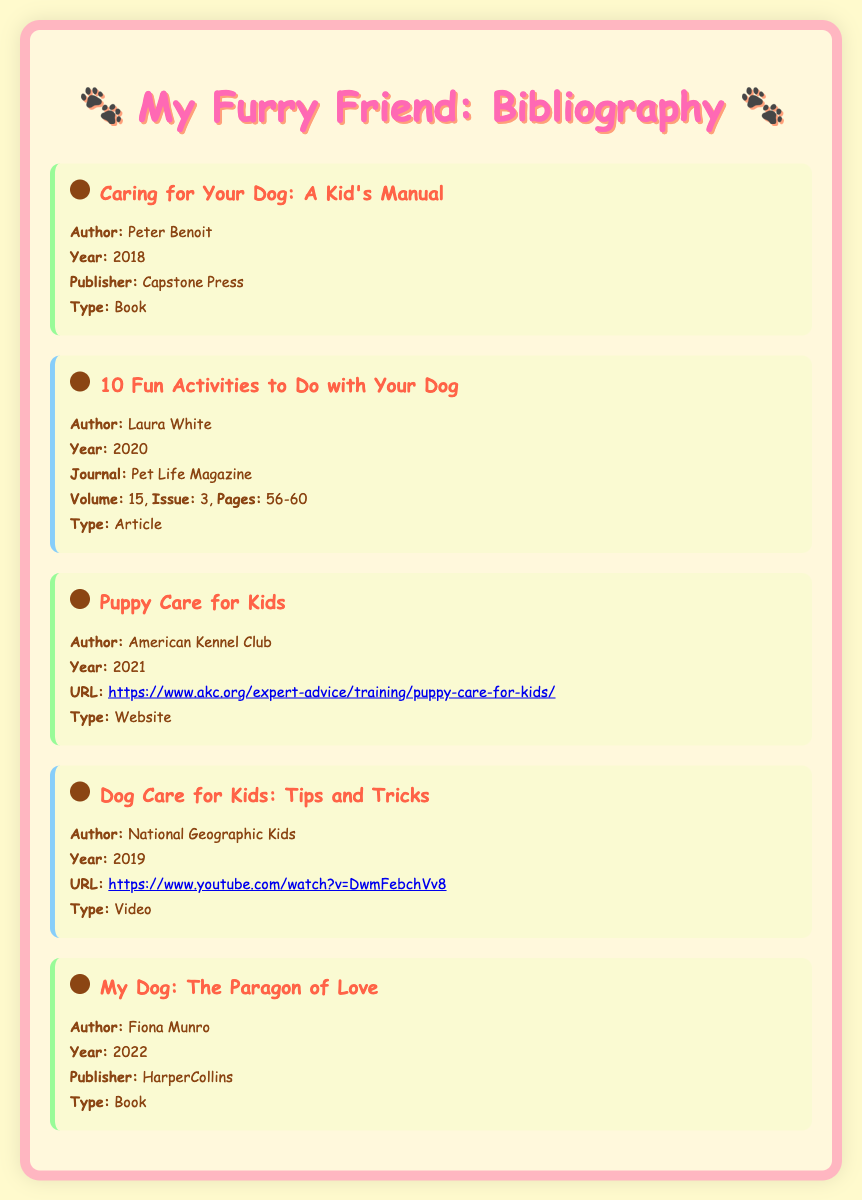What is the title of the first item? The title of the first item is the first entry listed in the bibliography.
Answer: Caring for Your Dog: A Kid's Manual Who is the author of "10 Fun Activities to Do with Your Dog"? The second entry shows the author's name for that specific article.
Answer: Laura White What year was "Puppy Care for Kids" published? The year is provided in the details of the third item listed.
Answer: 2021 What type of document is "Dog Care for Kids: Tips and Tricks"? The type indicates the format of the source as shown in the details of the fourth item.
Answer: Video How many pages is the article "10 Fun Activities to Do with Your Dog"? The pages are specified in the details of that bibliography entry.
Answer: 56-60 Which publisher is listed for "My Dog: The Paragon of Love"? The publisher is named in the details of the last item in the bibliography.
Answer: HarperCollins What is the URL of "Puppy Care for Kids"? The URL is found in the details of the third item and provides a link to the website.
Answer: https://www.akc.org/expert-advice/training/puppy-care-for-kids/ What is the volume number for "10 Fun Activities to Do with Your Dog"? The volume number is stated in the details about that article in the document.
Answer: 15 Which item was published in 2019? This question looks for the publication year associated with each item listed in the bibliography.
Answer: Dog Care for Kids: Tips and Tricks 